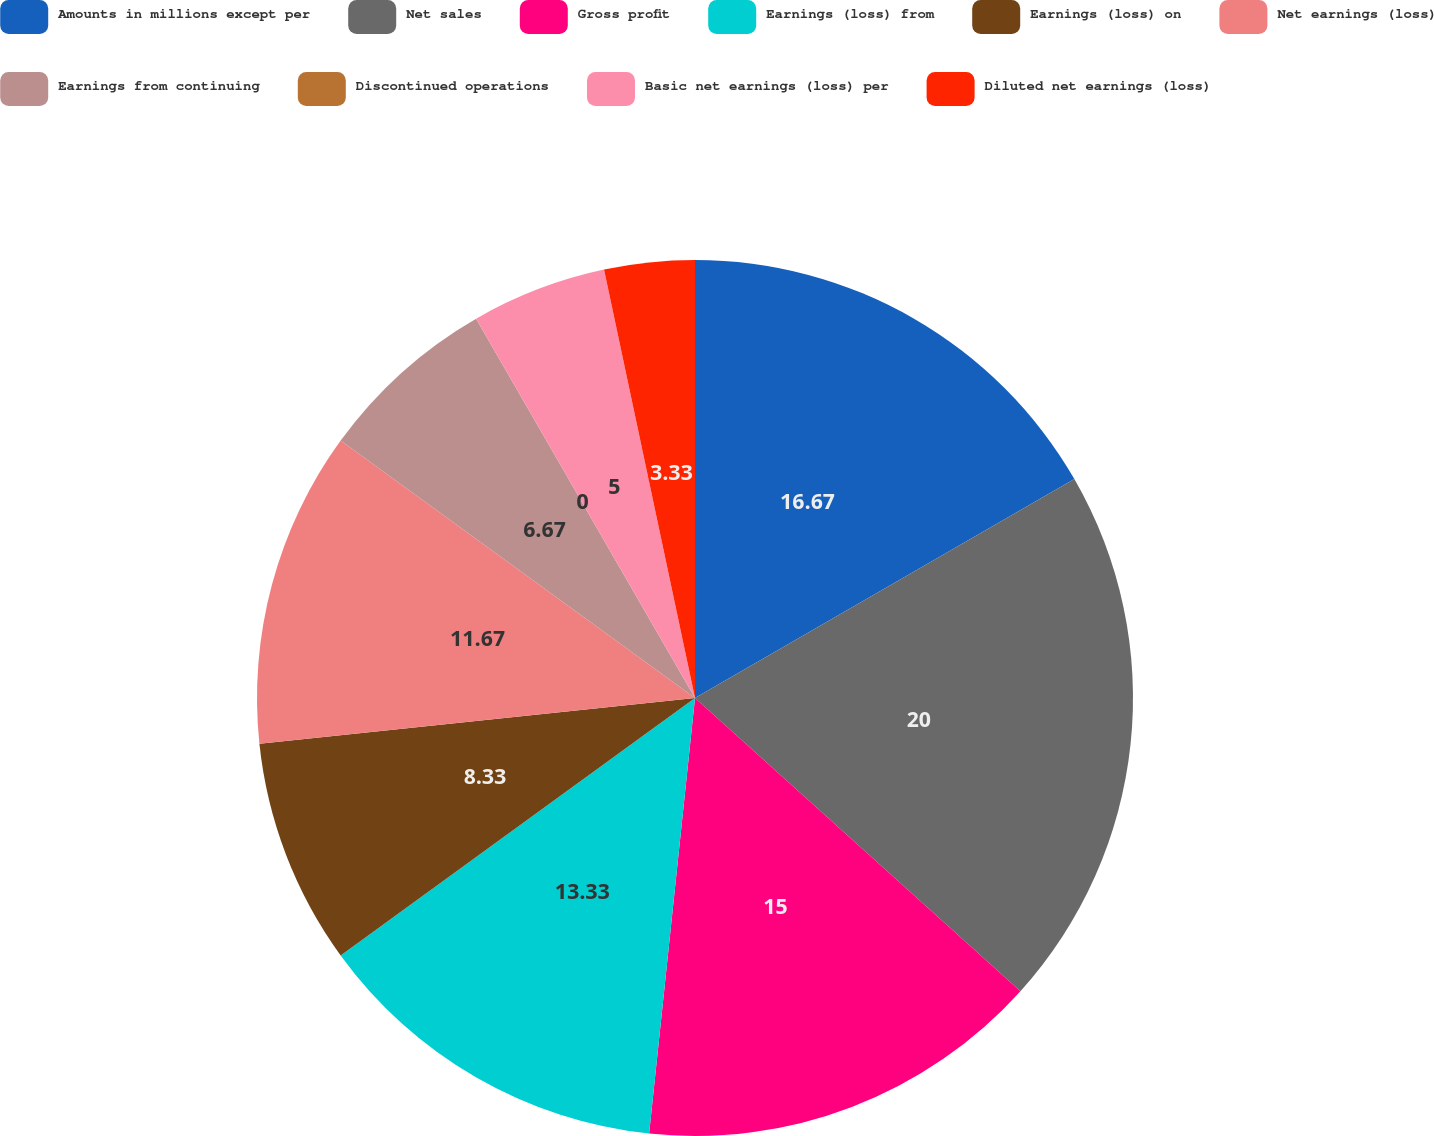Convert chart to OTSL. <chart><loc_0><loc_0><loc_500><loc_500><pie_chart><fcel>Amounts in millions except per<fcel>Net sales<fcel>Gross profit<fcel>Earnings (loss) from<fcel>Earnings (loss) on<fcel>Net earnings (loss)<fcel>Earnings from continuing<fcel>Discontinued operations<fcel>Basic net earnings (loss) per<fcel>Diluted net earnings (loss)<nl><fcel>16.67%<fcel>20.0%<fcel>15.0%<fcel>13.33%<fcel>8.33%<fcel>11.67%<fcel>6.67%<fcel>0.0%<fcel>5.0%<fcel>3.33%<nl></chart> 